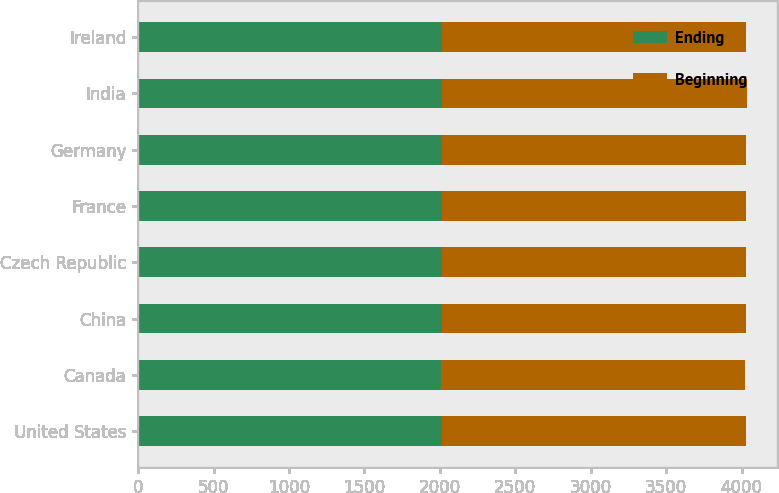Convert chart to OTSL. <chart><loc_0><loc_0><loc_500><loc_500><stacked_bar_chart><ecel><fcel>United States<fcel>Canada<fcel>China<fcel>Czech Republic<fcel>France<fcel>Germany<fcel>India<fcel>Ireland<nl><fcel>Ending<fcel>2014<fcel>2005<fcel>2012<fcel>2014<fcel>2015<fcel>2011<fcel>2017<fcel>2013<nl><fcel>Beginning<fcel>2017<fcel>2017<fcel>2017<fcel>2017<fcel>2017<fcel>2017<fcel>2017<fcel>2017<nl></chart> 